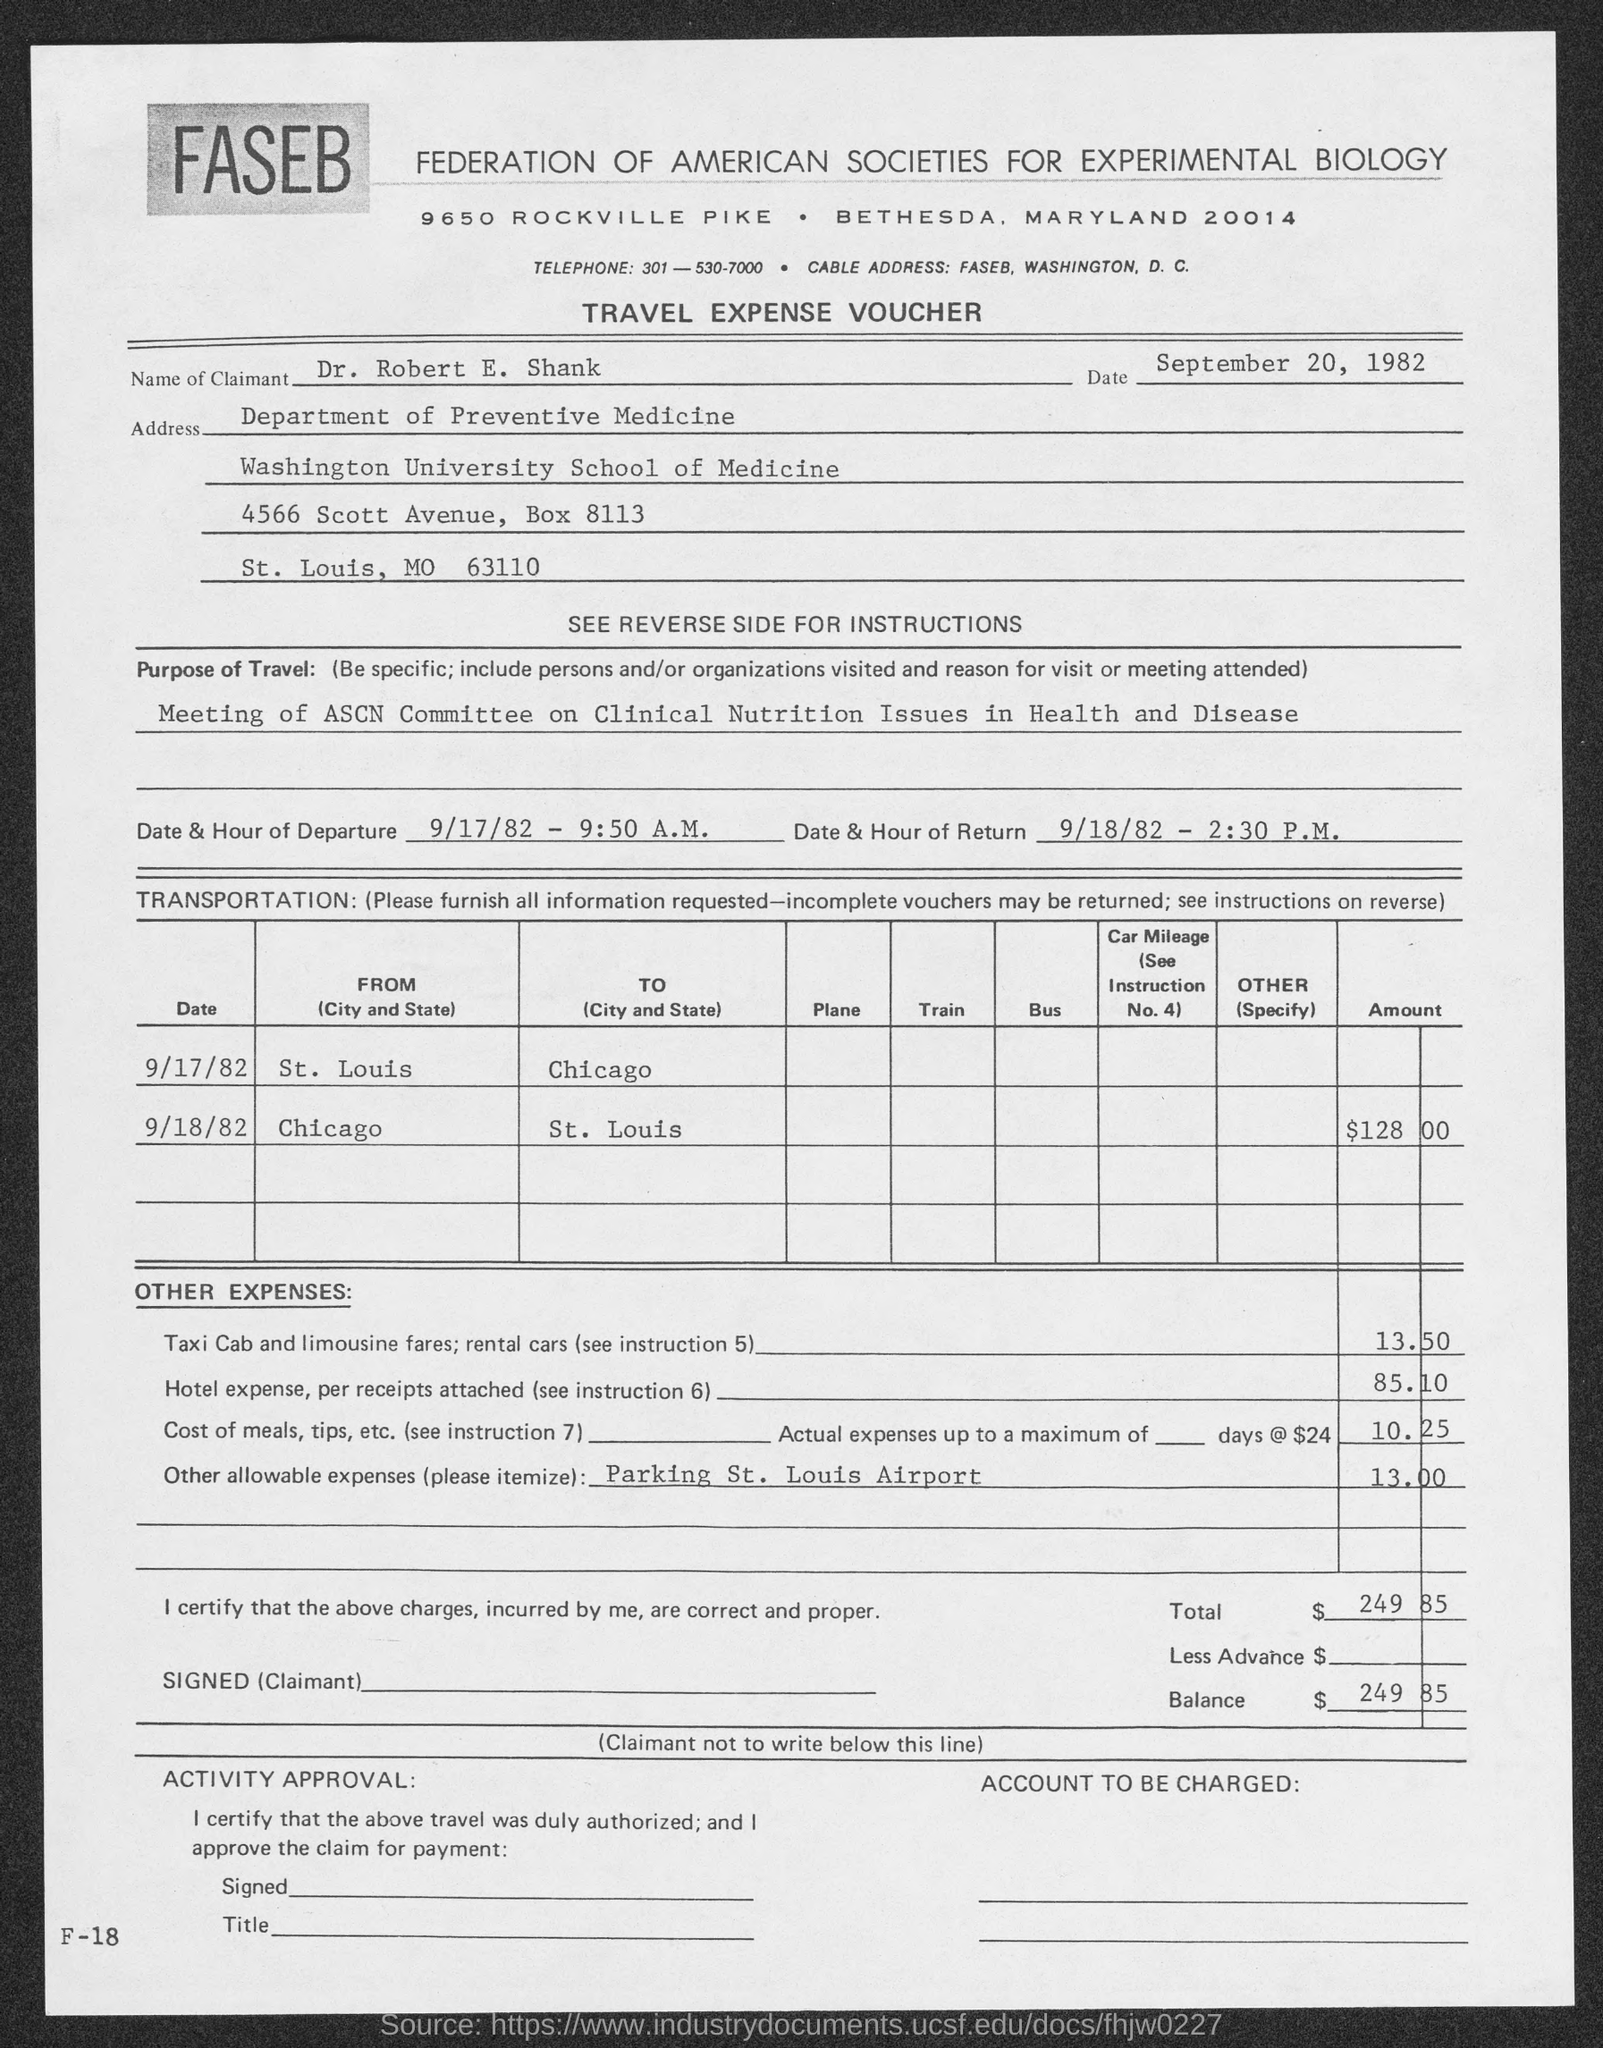List a handful of essential elements in this visual. The Federation of American Societies for Experimental Biology is located in the state of Maryland. 